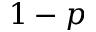<formula> <loc_0><loc_0><loc_500><loc_500>1 - p</formula> 